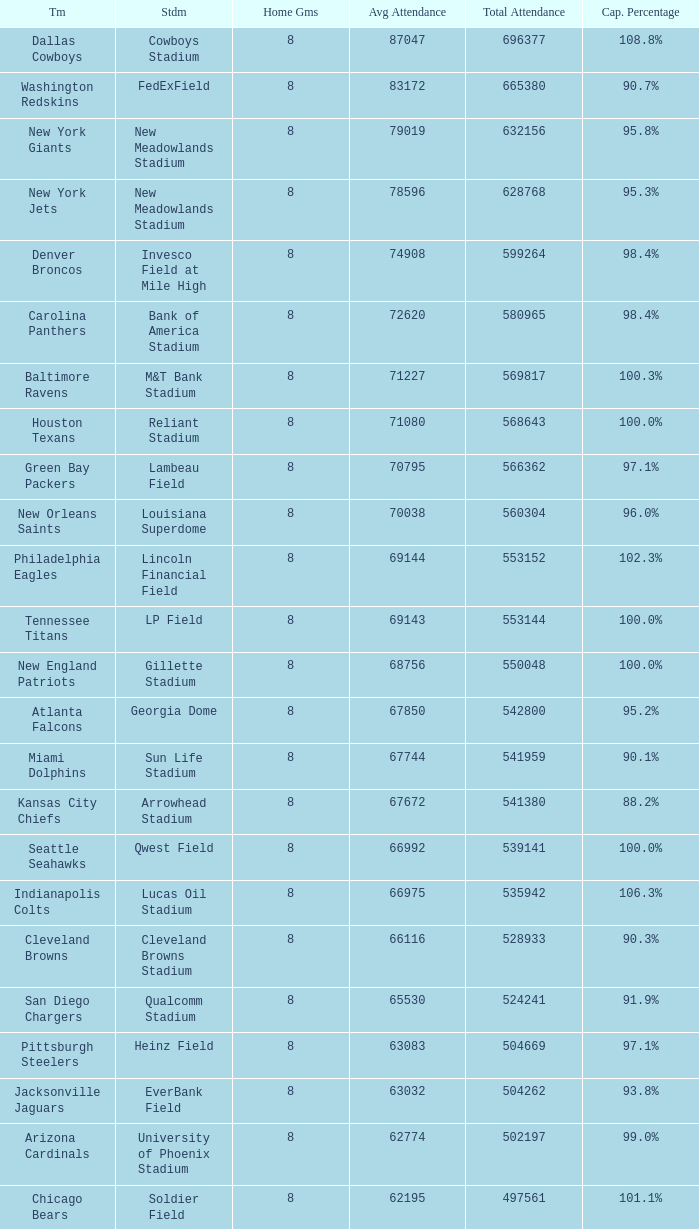Write the full table. {'header': ['Tm', 'Stdm', 'Home Gms', 'Avg Attendance', 'Total Attendance', 'Cap. Percentage'], 'rows': [['Dallas Cowboys', 'Cowboys Stadium', '8', '87047', '696377', '108.8%'], ['Washington Redskins', 'FedExField', '8', '83172', '665380', '90.7%'], ['New York Giants', 'New Meadowlands Stadium', '8', '79019', '632156', '95.8%'], ['New York Jets', 'New Meadowlands Stadium', '8', '78596', '628768', '95.3%'], ['Denver Broncos', 'Invesco Field at Mile High', '8', '74908', '599264', '98.4%'], ['Carolina Panthers', 'Bank of America Stadium', '8', '72620', '580965', '98.4%'], ['Baltimore Ravens', 'M&T Bank Stadium', '8', '71227', '569817', '100.3%'], ['Houston Texans', 'Reliant Stadium', '8', '71080', '568643', '100.0%'], ['Green Bay Packers', 'Lambeau Field', '8', '70795', '566362', '97.1%'], ['New Orleans Saints', 'Louisiana Superdome', '8', '70038', '560304', '96.0%'], ['Philadelphia Eagles', 'Lincoln Financial Field', '8', '69144', '553152', '102.3%'], ['Tennessee Titans', 'LP Field', '8', '69143', '553144', '100.0%'], ['New England Patriots', 'Gillette Stadium', '8', '68756', '550048', '100.0%'], ['Atlanta Falcons', 'Georgia Dome', '8', '67850', '542800', '95.2%'], ['Miami Dolphins', 'Sun Life Stadium', '8', '67744', '541959', '90.1%'], ['Kansas City Chiefs', 'Arrowhead Stadium', '8', '67672', '541380', '88.2%'], ['Seattle Seahawks', 'Qwest Field', '8', '66992', '539141', '100.0%'], ['Indianapolis Colts', 'Lucas Oil Stadium', '8', '66975', '535942', '106.3%'], ['Cleveland Browns', 'Cleveland Browns Stadium', '8', '66116', '528933', '90.3%'], ['San Diego Chargers', 'Qualcomm Stadium', '8', '65530', '524241', '91.9%'], ['Pittsburgh Steelers', 'Heinz Field', '8', '63083', '504669', '97.1%'], ['Jacksonville Jaguars', 'EverBank Field', '8', '63032', '504262', '93.8%'], ['Arizona Cardinals', 'University of Phoenix Stadium', '8', '62774', '502197', '99.0%'], ['Chicago Bears', 'Soldier Field', '8', '62195', '497561', '101.1%'], ['San Francisco 49ers', 'Candlestick Park', '7', '69732', '488124', '99.3%'], ['Cincinnati Bengals', 'Paul Brown Stadium', '8', '60364', '482917', '92.1%'], ['Minnesota Vikings', 'Hubert H. Humphrey Metrodome **', '8', '58751', '470009', '94.1%'], ['Detroit Lions', 'Ford Field', '8', '56285', '450286', '87.3%'], ['Buffalo Bills', 'Ralph Wilson Stadium **', '7', '63195', '442366', '86.5%'], ['St. Louis Rams', 'Edward Jones Dome', '8', '52922', '423383', '81.0%'], ['Tampa Bay Buccaneers', 'Raymond James Stadium', '8', '49314', '394513', '75.1%']]} How many teams had a 99.3% capacity rating? 1.0. 